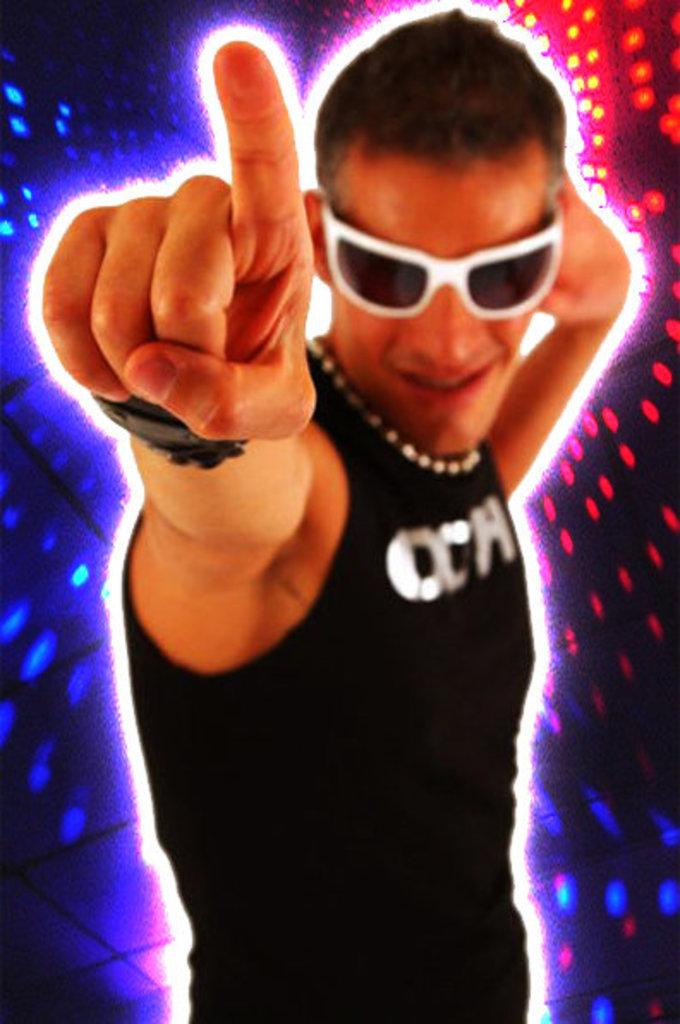Who is present in the image? There is a man in the image. What accessory is the man wearing? The man is wearing glasses. What can be seen in the background of the image? There are colorful lights in the background of the image. What type of jelly can be seen on the man's face in the image? There is no jelly present on the man's face in the image. 